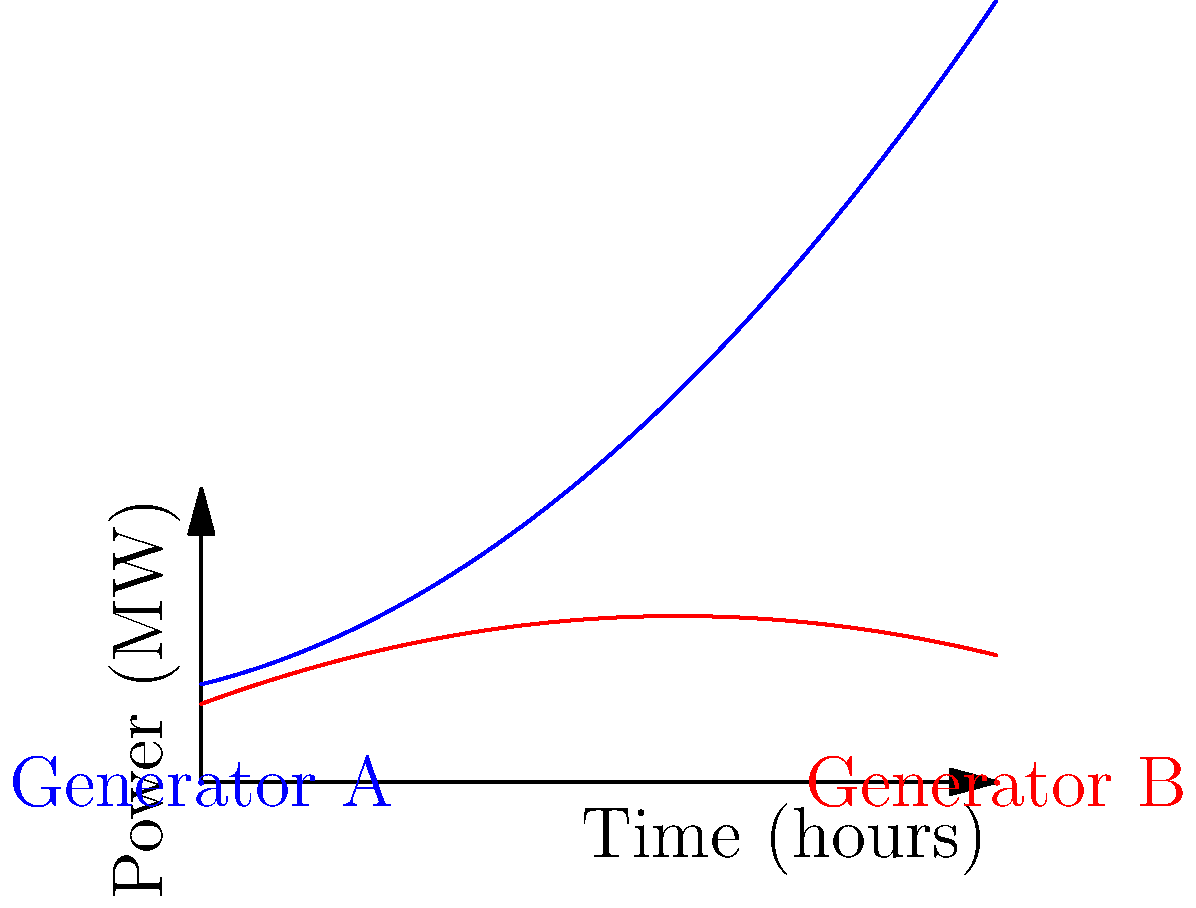A shipboard power system utilizes two generators, A and B, whose power outputs over time are represented by the blue and red curves respectively. Generator A's output is modeled by $P_A(t) = 0.5t^2 + 2t + 10$, and Generator B's output by $P_B(t) = -0.25t^2 + 3t + 8$, where $P$ is power in MW and $t$ is time in hours. Calculate the total energy produced by both generators over a 10-hour period. To solve this problem, we need to follow these steps:

1) The energy produced by each generator is represented by the area under its respective curve over the 10-hour period.

2) To find the area under each curve, we need to integrate the power functions from t = 0 to t = 10.

3) For Generator A:
   $$E_A = \int_0^{10} (0.5t^2 + 2t + 10) dt$$
   $$= [\frac{1}{6}t^3 + t^2 + 10t]_0^{10}$$
   $$= (\frac{1000}{6} + 100 + 100) - (0 + 0 + 0) = 366.67 \text{ MWh}$$

4) For Generator B:
   $$E_B = \int_0^{10} (-0.25t^2 + 3t + 8) dt$$
   $$= [-\frac{1}{12}t^3 + \frac{3}{2}t^2 + 8t]_0^{10}$$
   $$= (-83.33 + 150 + 80) - (0 + 0 + 0) = 146.67 \text{ MWh}$$

5) The total energy is the sum of energies from both generators:
   $$E_{total} = E_A + E_B = 366.67 + 146.67 = 513.34 \text{ MWh}$$
Answer: 513.34 MWh 